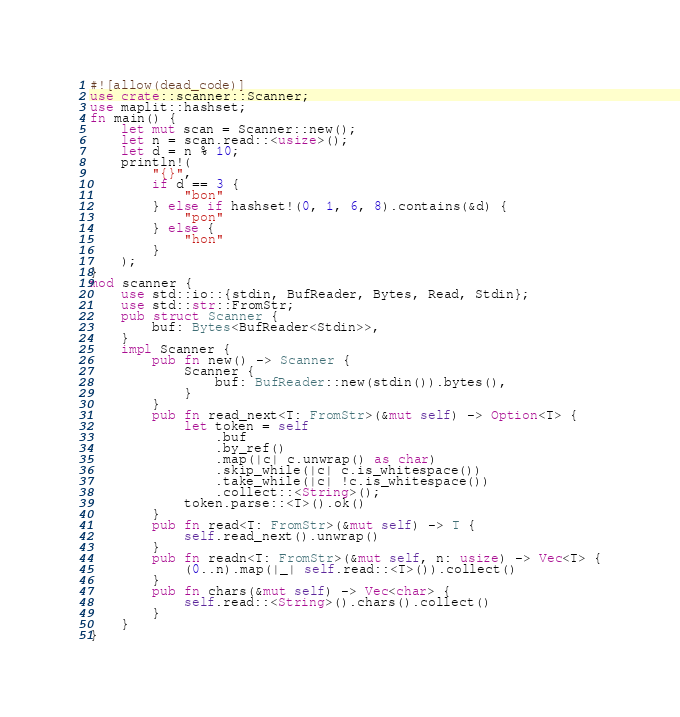Convert code to text. <code><loc_0><loc_0><loc_500><loc_500><_Rust_>#![allow(dead_code)]
use crate::scanner::Scanner;
use maplit::hashset;
fn main() {
    let mut scan = Scanner::new();
    let n = scan.read::<usize>();
    let d = n % 10;
    println!(
        "{}",
        if d == 3 {
            "bon"
        } else if hashset!(0, 1, 6, 8).contains(&d) {
            "pon"
        } else {
            "hon"
        }
    );
}
mod scanner {
    use std::io::{stdin, BufReader, Bytes, Read, Stdin};
    use std::str::FromStr;
    pub struct Scanner {
        buf: Bytes<BufReader<Stdin>>,
    }
    impl Scanner {
        pub fn new() -> Scanner {
            Scanner {
                buf: BufReader::new(stdin()).bytes(),
            }
        }
        pub fn read_next<T: FromStr>(&mut self) -> Option<T> {
            let token = self
                .buf
                .by_ref()
                .map(|c| c.unwrap() as char)
                .skip_while(|c| c.is_whitespace())
                .take_while(|c| !c.is_whitespace())
                .collect::<String>();
            token.parse::<T>().ok()
        }
        pub fn read<T: FromStr>(&mut self) -> T {
            self.read_next().unwrap()
        }
        pub fn readn<T: FromStr>(&mut self, n: usize) -> Vec<T> {
            (0..n).map(|_| self.read::<T>()).collect()
        }
        pub fn chars(&mut self) -> Vec<char> {
            self.read::<String>().chars().collect()
        }
    }
}

</code> 